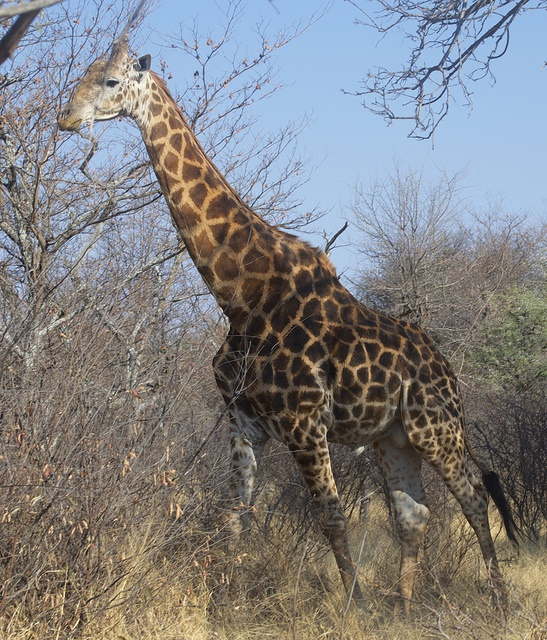Describe the objects in this image and their specific colors. I can see a giraffe in lightblue, black, gray, and maroon tones in this image. 